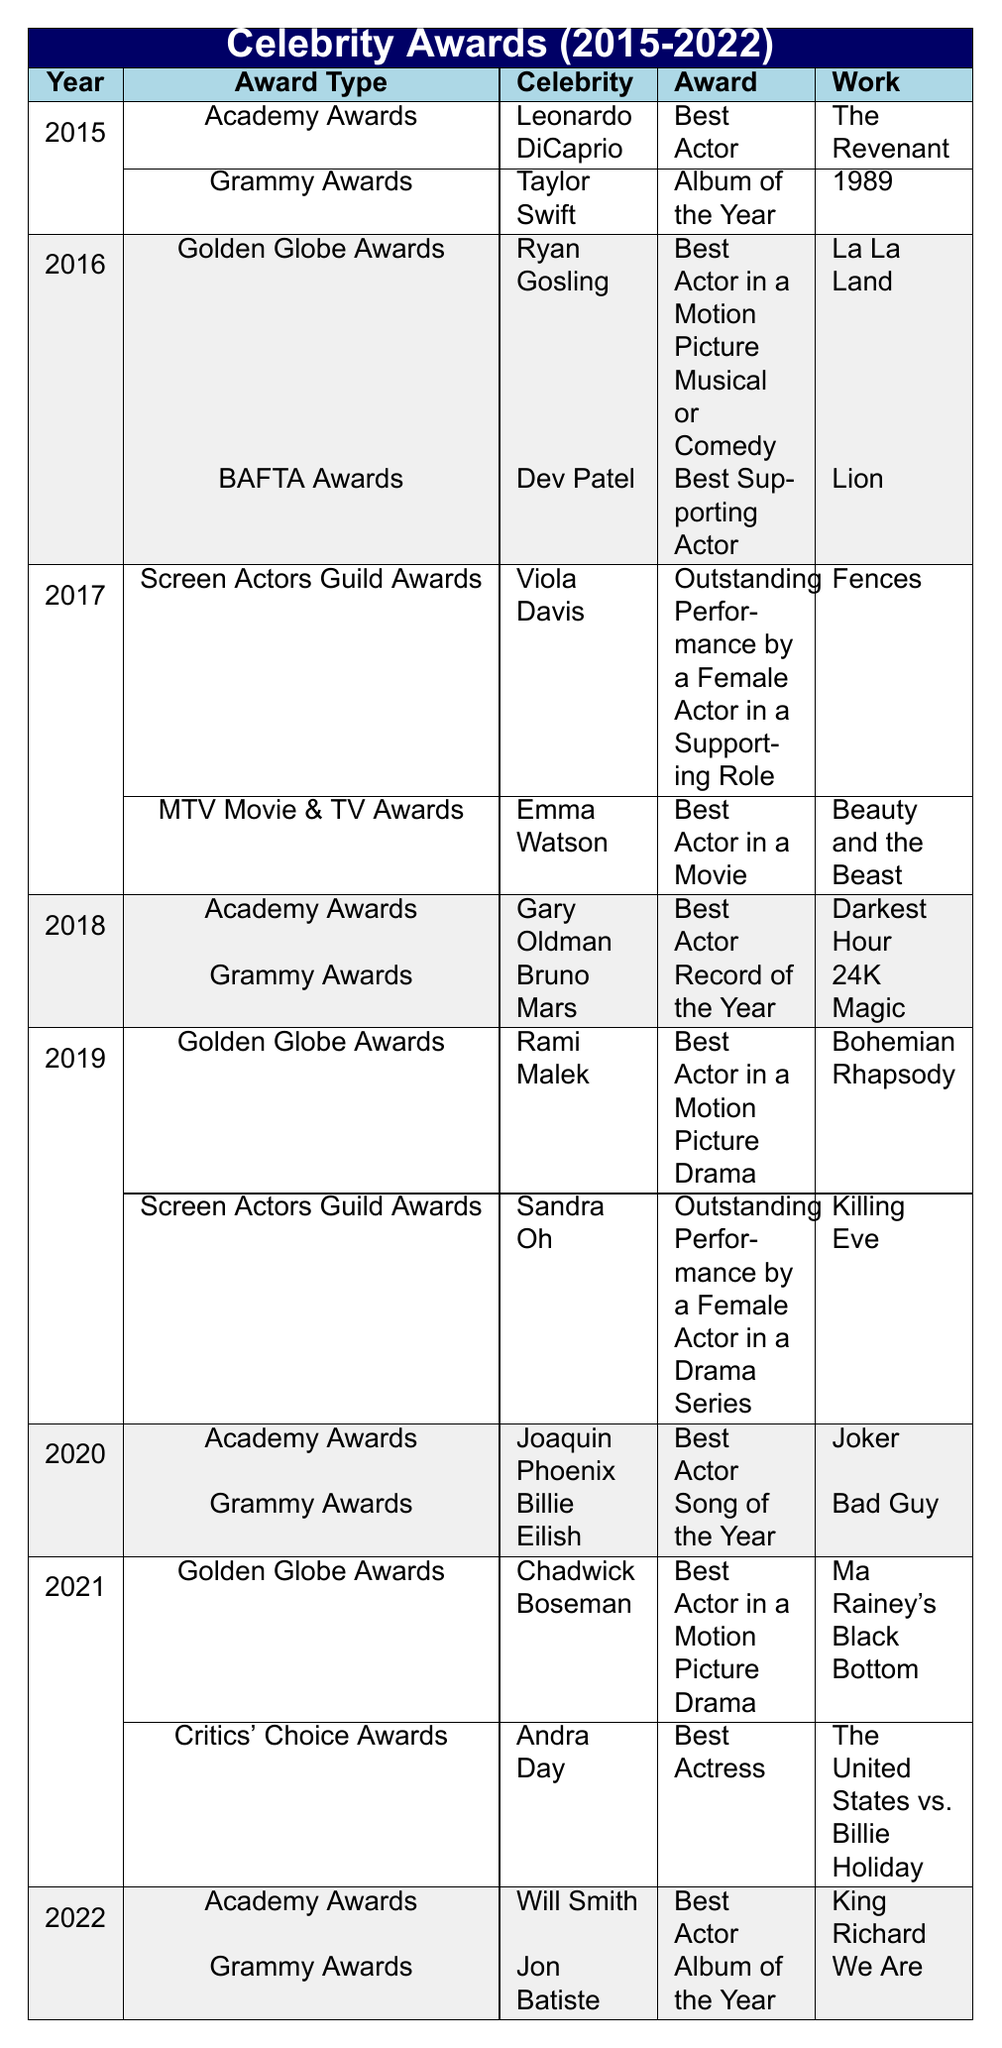What celebrity won the Grammy Award for Album of the Year in 2015? According to the table, in 2015, the Grammy Award for Album of the Year was awarded to Taylor Swift for her album titled "1989."
Answer: Taylor Swift Which movie earned Joaquin Phoenix the Academy Award in 2020? The table indicates that Joaquin Phoenix won the Academy Award for Best Actor in 2020 for the movie "Joker."
Answer: Joker How many different types of awards did Viola Davis receive between 2015 and 2022? From the table, Viola Davis received the Screen Actors Guild Award for Outstanding Performance by a Female Actor in a Supporting Role in 2017. No other types of awards are listed for her from 2015 to 2022. Thus, she received 1 type of award.
Answer: 1 Who won the Best Actor award in the years 2016 and 2017? According to the data, Ryan Gosling won Best Actor in 2016 at the Golden Globe Awards for "La La Land," and Viola Davis received an acting award in 2017 but it was a supporting role and not for Best Actor. Therefore, the direct answer for Best Actor is Ryan Gosling for 2016 and no Best Actor was noted for 2017.
Answer: Ryan Gosling in 2016; no Best Actor in 2017 Did Gary Oldman win an Academy Award for his work in 2018? Yes, the table confirms that Gary Oldman won the Academy Award for Best Actor in 2018 for his performance in "Darkest Hour."
Answer: Yes Which award was given for the movie "Fences"? The table shows that Viola Davis received an award for her role in the movie "Fences," specifically the Screen Actors Guild Award for Outstanding Performance by a Female Actor in a Supporting Role.
Answer: Screen Actors Guild Award Across the years listed, how many times did the Academy Awards present the Best Actor award? From the table, the Best Actor award was presented in the years 2015, 2018, 2020, 2021, and 2022. That gives a total of 4 instances where the Academy Awards presented the Best Actor award.
Answer: 4 Was there a year where both a Grammy Award and an Academy Award were presented? Yes, in 2018, both Gary Oldman received the Academy Award for Best Actor and Bruno Mars won the Grammy Award for Record of the Year.
Answer: Yes 